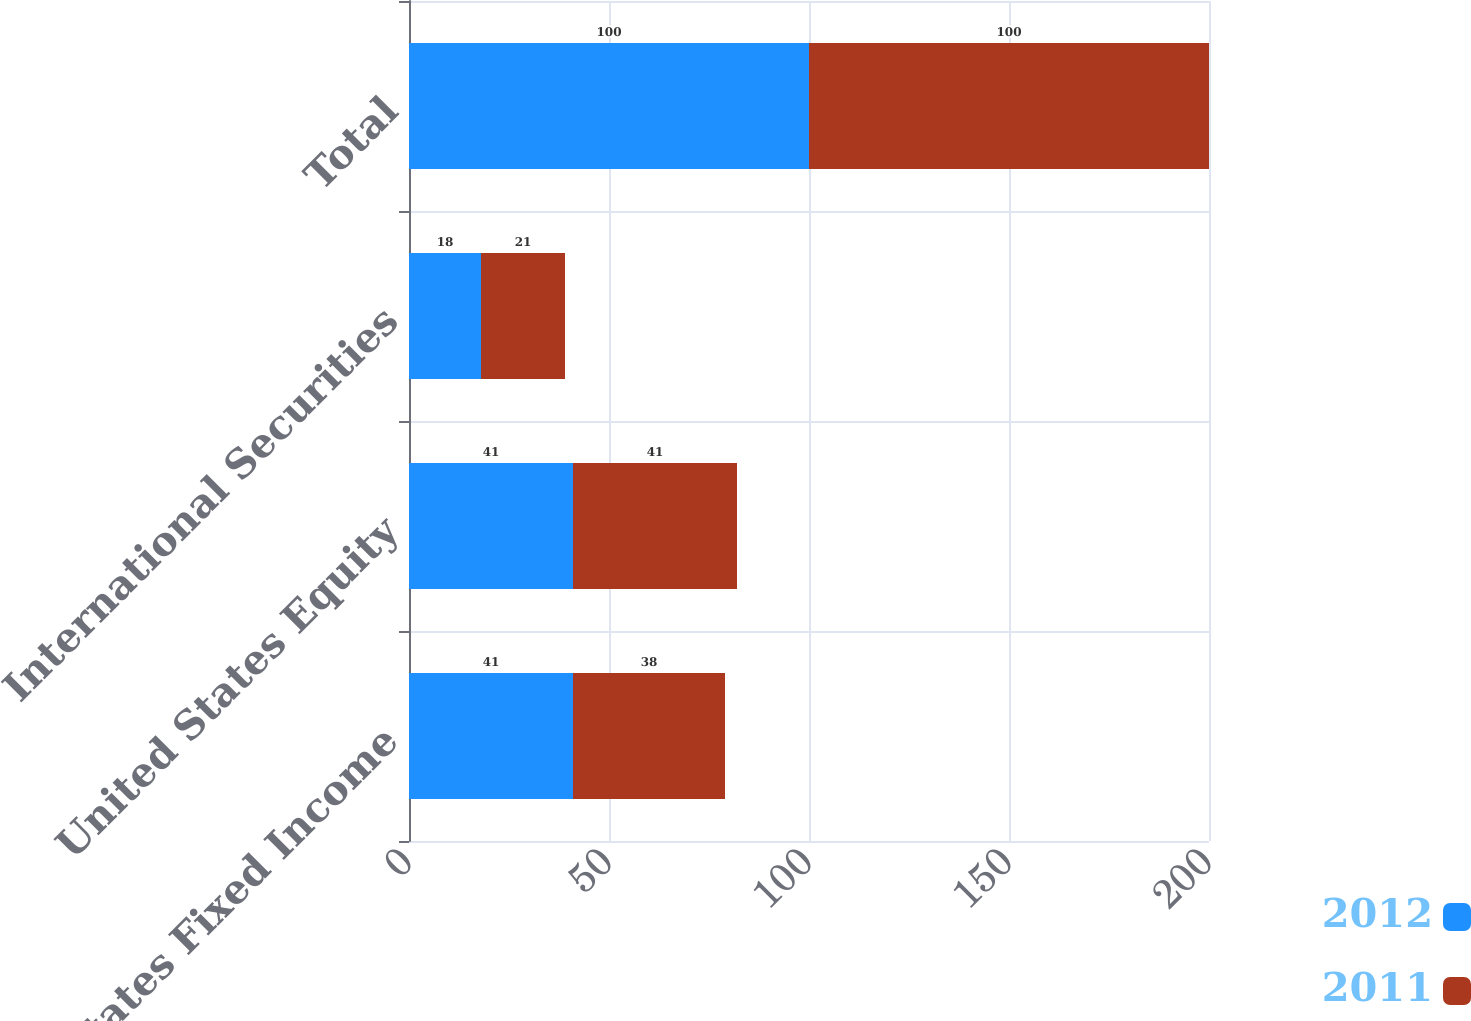Convert chart. <chart><loc_0><loc_0><loc_500><loc_500><stacked_bar_chart><ecel><fcel>United States Fixed Income<fcel>United States Equity<fcel>International Securities<fcel>Total<nl><fcel>2012<fcel>41<fcel>41<fcel>18<fcel>100<nl><fcel>2011<fcel>38<fcel>41<fcel>21<fcel>100<nl></chart> 